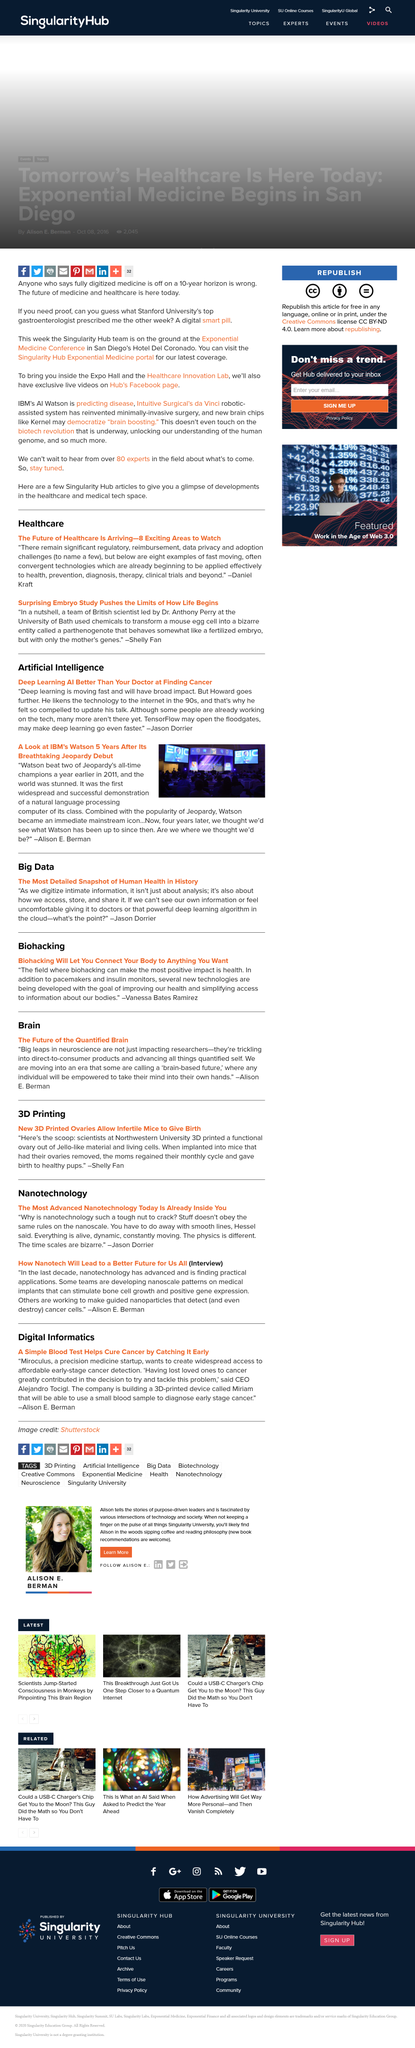Mention a couple of crucial points in this snapshot. Dr. Anthony Perry of the University of Bath led a groundbreaking study on the origins of life that challenged conventional wisdom and expanded our understanding of the beginning of life. According to Jason Dorrier, TensorFlow has the potential to open the floodgates and significantly accelerate the pace of deep learning. A parthenogenote is a bizarre entity that exhibits characteristics of a fertilized embryo, but is created through the process of parthenogenesis and contains only the mother's genetic material. Daniel Kraft offers eight examples of fast-moving, often convergent technologies. In 2011, Watson, a machine learning system, competed on the game show Jeopardy and defeated two all-time champions. 